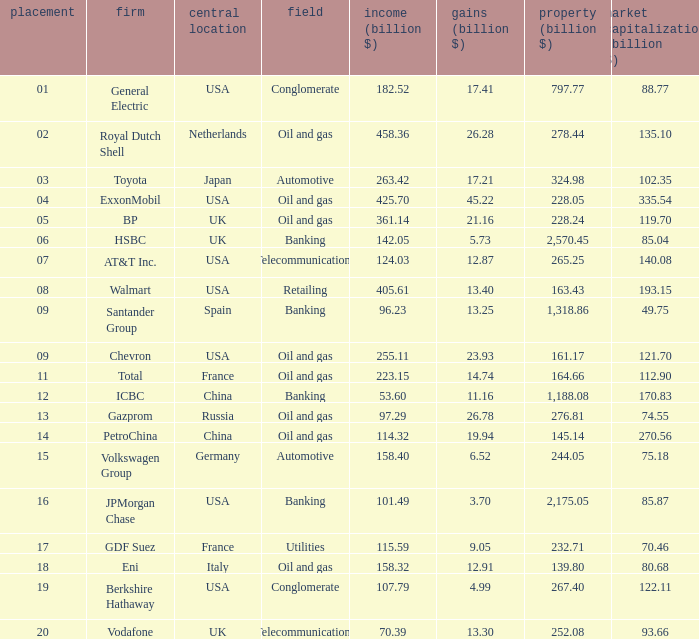Can you give me this table as a dict? {'header': ['placement', 'firm', 'central location', 'field', 'income (billion $)', 'gains (billion $)', 'property (billion $)', 'market capitalization (billion $)'], 'rows': [['01', 'General Electric', 'USA', 'Conglomerate', '182.52', '17.41', '797.77', '88.77'], ['02', 'Royal Dutch Shell', 'Netherlands', 'Oil and gas', '458.36', '26.28', '278.44', '135.10'], ['03', 'Toyota', 'Japan', 'Automotive', '263.42', '17.21', '324.98', '102.35'], ['04', 'ExxonMobil', 'USA', 'Oil and gas', '425.70', '45.22', '228.05', '335.54'], ['05', 'BP', 'UK', 'Oil and gas', '361.14', '21.16', '228.24', '119.70'], ['06', 'HSBC', 'UK', 'Banking', '142.05', '5.73', '2,570.45', '85.04'], ['07', 'AT&T Inc.', 'USA', 'Telecommunications', '124.03', '12.87', '265.25', '140.08'], ['08', 'Walmart', 'USA', 'Retailing', '405.61', '13.40', '163.43', '193.15'], ['09', 'Santander Group', 'Spain', 'Banking', '96.23', '13.25', '1,318.86', '49.75'], ['09', 'Chevron', 'USA', 'Oil and gas', '255.11', '23.93', '161.17', '121.70'], ['11', 'Total', 'France', 'Oil and gas', '223.15', '14.74', '164.66', '112.90'], ['12', 'ICBC', 'China', 'Banking', '53.60', '11.16', '1,188.08', '170.83'], ['13', 'Gazprom', 'Russia', 'Oil and gas', '97.29', '26.78', '276.81', '74.55'], ['14', 'PetroChina', 'China', 'Oil and gas', '114.32', '19.94', '145.14', '270.56'], ['15', 'Volkswagen Group', 'Germany', 'Automotive', '158.40', '6.52', '244.05', '75.18'], ['16', 'JPMorgan Chase', 'USA', 'Banking', '101.49', '3.70', '2,175.05', '85.87'], ['17', 'GDF Suez', 'France', 'Utilities', '115.59', '9.05', '232.71', '70.46'], ['18', 'Eni', 'Italy', 'Oil and gas', '158.32', '12.91', '139.80', '80.68'], ['19', 'Berkshire Hathaway', 'USA', 'Conglomerate', '107.79', '4.99', '267.40', '122.11'], ['20', 'Vodafone', 'UK', 'Telecommunications', '70.39', '13.30', '252.08', '93.66']]} Name the lowest Profits (billion $) which has a Sales (billion $) of 425.7, and a Rank larger than 4? None. 